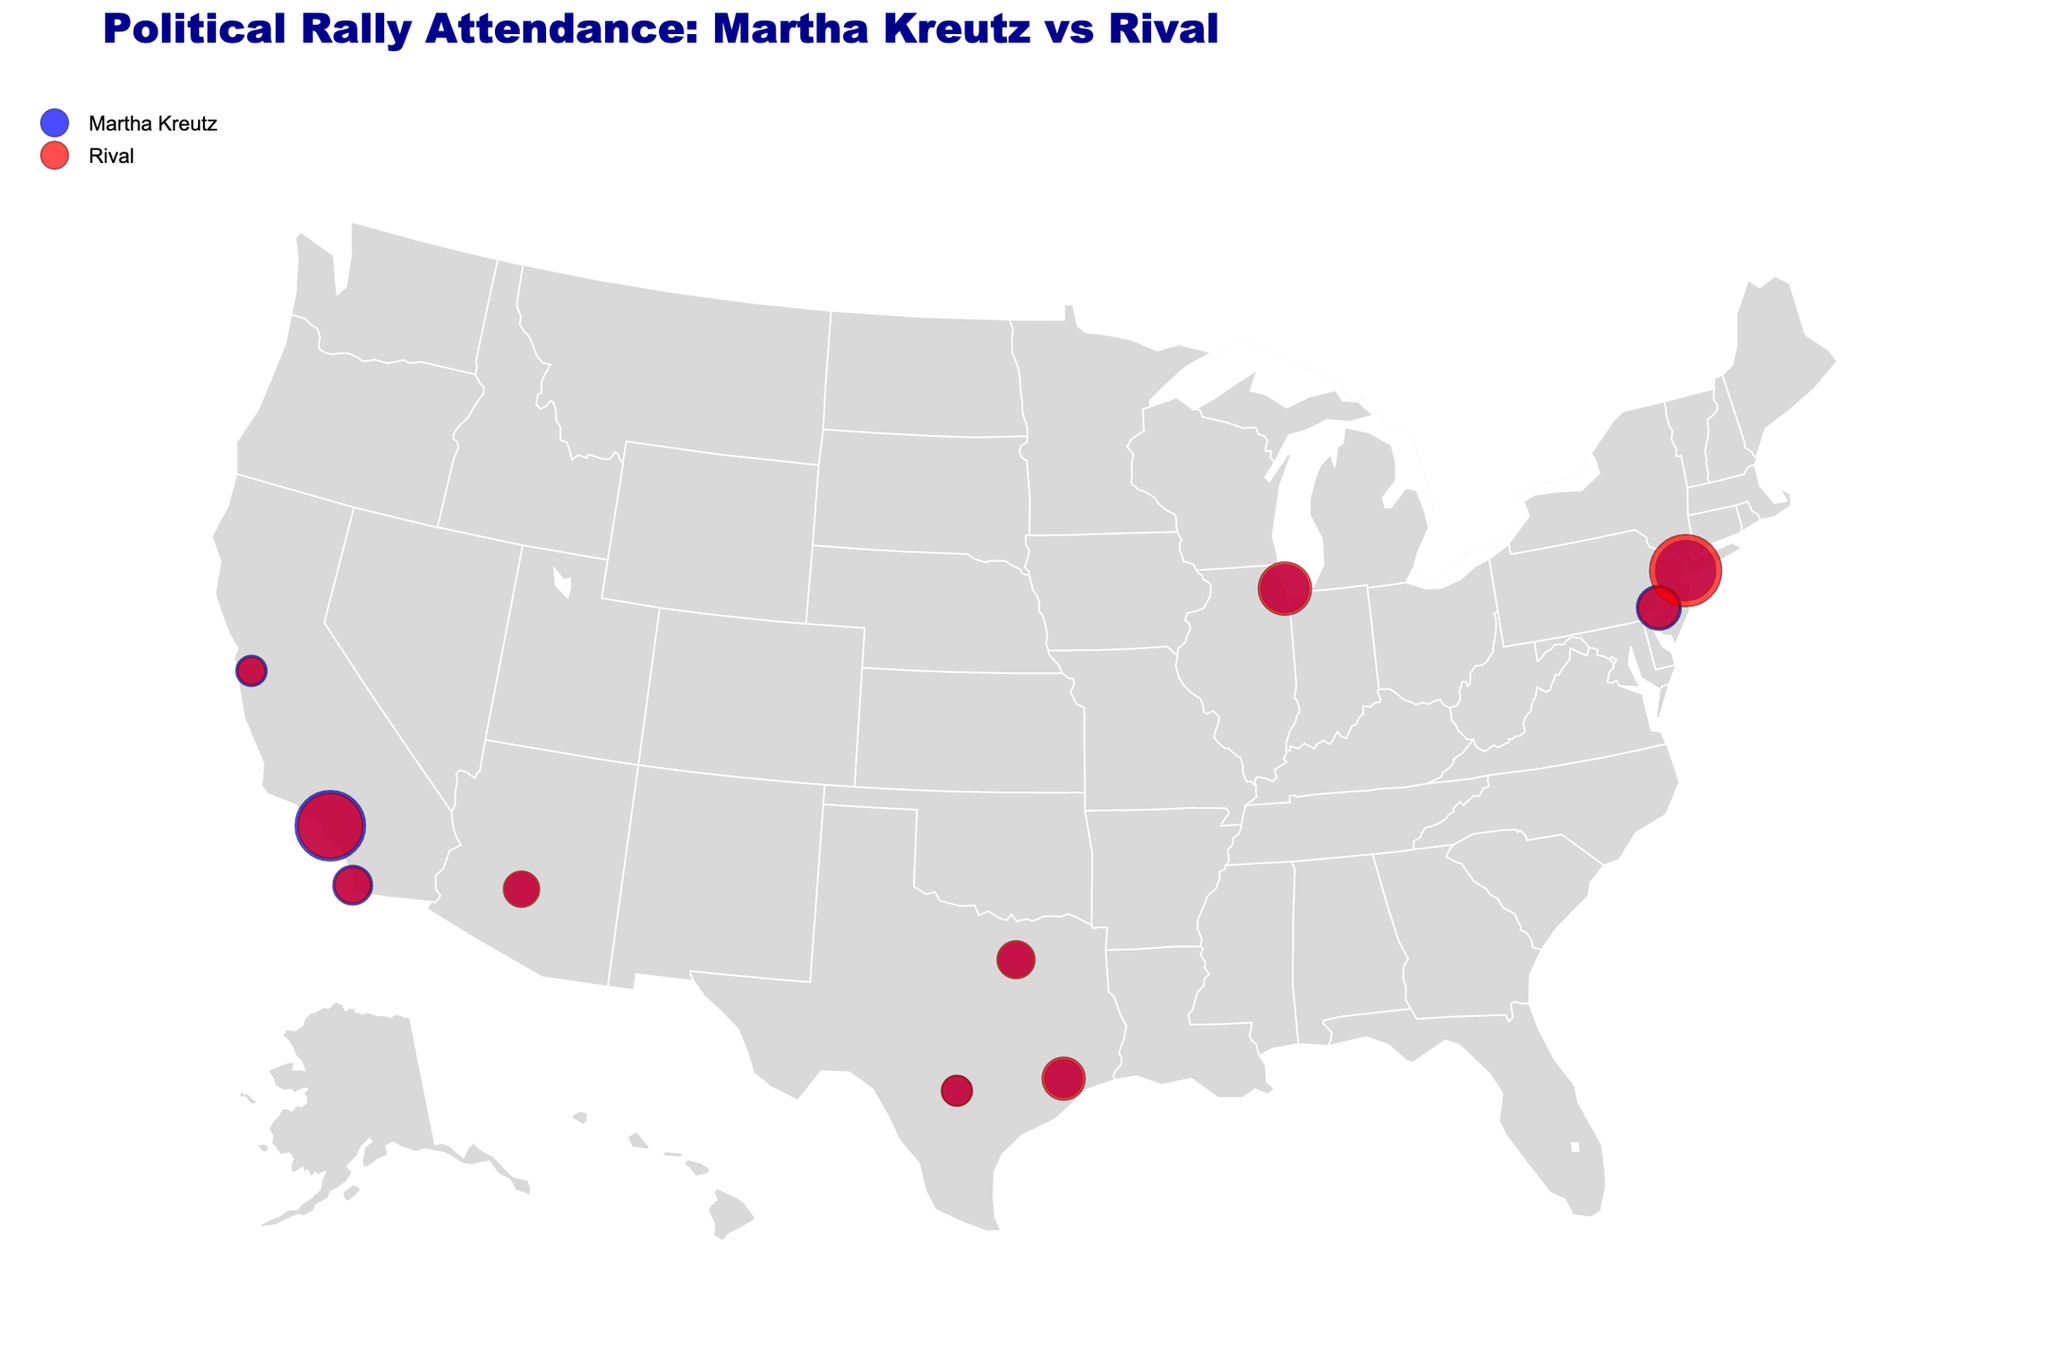What city had the highest attendance for Martha Kreutz's rally? The figure shows circles representing attendance. The largest blue circle, which represents Martha Kreutz's rally, is in Los Angeles.
Answer: Los Angeles Which city had the lowest attendance for Martha Kreutz's rally? The figure shows smaller blue circles for lower attendance. The smallest blue circle is in San Antonio.
Answer: San Antonio What is the overall trend comparing attendance rates between Martha Kreutz and her rival? By observing the relative sizes of the blue and red circles, Kreutz's rival generally has larger circles indicating higher attendance rates in most cities.
Answer: Rival generally has higher attendance How many cities have higher attendance rates for the rival compared to Martha Kreutz? Compare the relative sizes of red and blue circles. The rival has higher attendance in New York, Chicago, Houston, Phoenix, San Antonio, and Dallas. That's 6 cities.
Answer: 6 cities Which city shows the smallest difference in attendance between Martha Kreutz and her rival? Calculate the attendance difference for each city. The smallest difference is 100 in San Antonio.
Answer: San Antonio What is the sum of attendance for Martha Kreutz in New York and Los Angeles? The attendance for Kreutz in New York is 3500, and in Los Angeles, it's 4100. Sum: 3500 + 4100 = 7600.
Answer: 7600 In which city is the ratio of rival to Kreutz's attendance the highest? Calculate the attendance ratio for each city. The highest ratio is in Chicago, where the ratio is 3100/2800 ≈ 1.11.
Answer: Chicago What is the average attendance at Martha Kreutz's rallies across all cities? Sum up all attendance numbers and divide by the number of cities. (3500 + 2800 + 4100 + 2200 + 1900 + 2600 + 1700 + 2300 + 2000 + 1800)/10 = 2490.0
Answer: 2490.0 How does the attendance in San Diego compare between Martha Kreutz and her rival? Compare the sizes of the blue and red circles in San Diego. Martha Kreutz's attendance is 2300, and her rival's attendance is 2100, so Kreutz has higher attendance.
Answer: Kreutz has higher attendance Which city's attendance rates for Martha Kreutz and her rival are closest to being equal? Identify the city where the size of blue and red circles are most similar. Philadelphia has Kreutz at 2600 and her rival at 2400, a difference of 200, the smallest difference other than San Antonio.
Answer: Philadelphia 